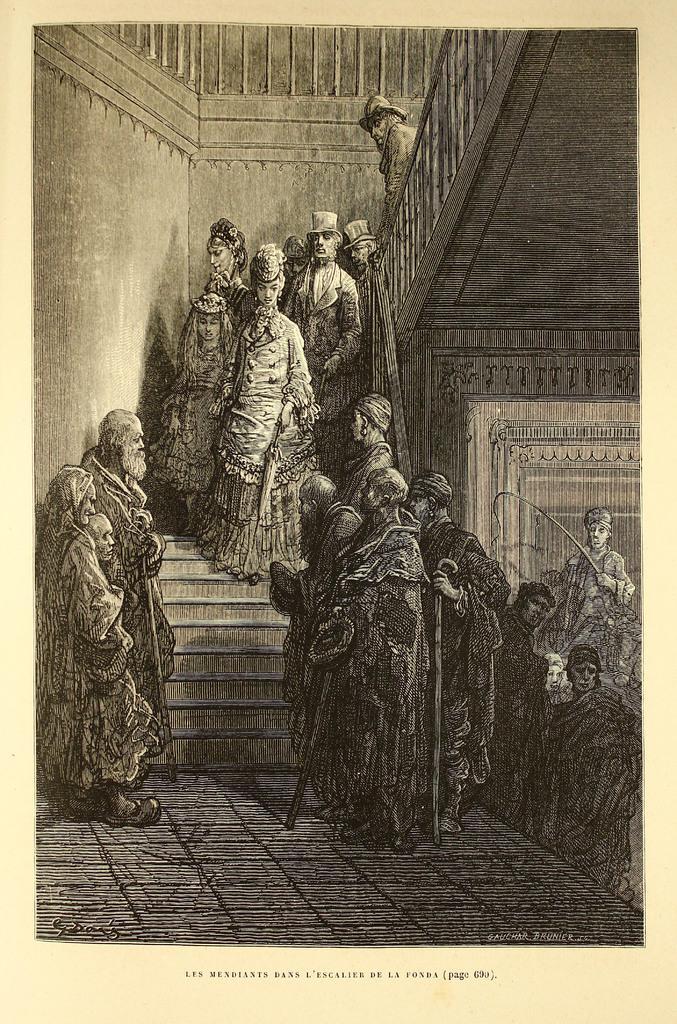Please provide a concise description of this image. This is a black and white photography. In this image we can see persons standing on the floor and some are climbing the stairs. 